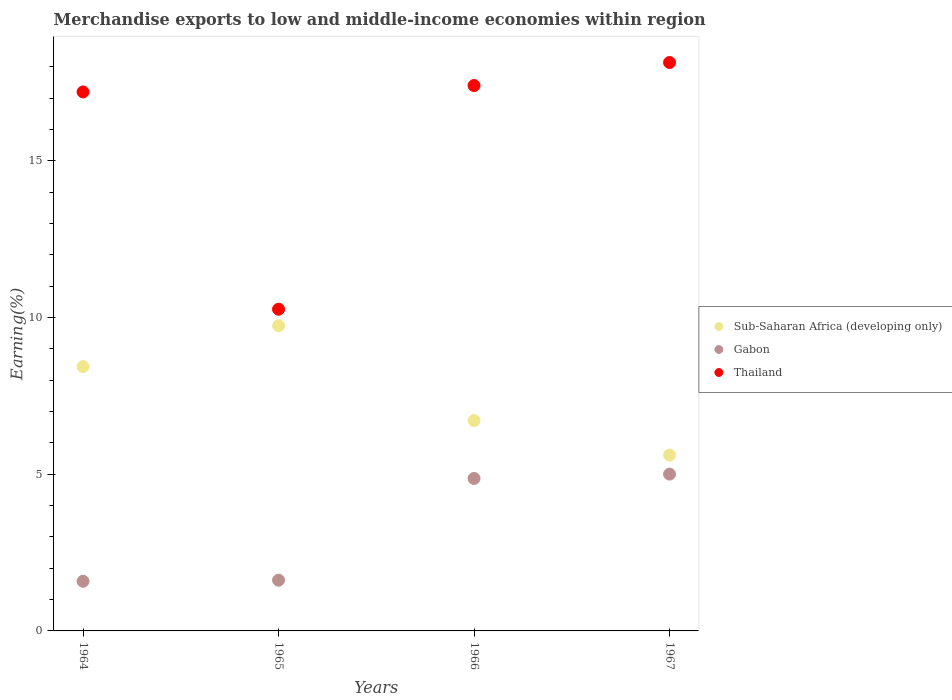What is the percentage of amount earned from merchandise exports in Gabon in 1967?
Provide a succinct answer. 5. Across all years, what is the maximum percentage of amount earned from merchandise exports in Sub-Saharan Africa (developing only)?
Provide a succinct answer. 9.74. Across all years, what is the minimum percentage of amount earned from merchandise exports in Thailand?
Offer a terse response. 10.27. In which year was the percentage of amount earned from merchandise exports in Sub-Saharan Africa (developing only) maximum?
Keep it short and to the point. 1965. In which year was the percentage of amount earned from merchandise exports in Sub-Saharan Africa (developing only) minimum?
Provide a short and direct response. 1967. What is the total percentage of amount earned from merchandise exports in Sub-Saharan Africa (developing only) in the graph?
Provide a succinct answer. 30.5. What is the difference between the percentage of amount earned from merchandise exports in Thailand in 1966 and that in 1967?
Ensure brevity in your answer.  -0.73. What is the difference between the percentage of amount earned from merchandise exports in Thailand in 1966 and the percentage of amount earned from merchandise exports in Sub-Saharan Africa (developing only) in 1965?
Give a very brief answer. 7.67. What is the average percentage of amount earned from merchandise exports in Gabon per year?
Provide a succinct answer. 3.27. In the year 1967, what is the difference between the percentage of amount earned from merchandise exports in Sub-Saharan Africa (developing only) and percentage of amount earned from merchandise exports in Gabon?
Offer a very short reply. 0.61. In how many years, is the percentage of amount earned from merchandise exports in Gabon greater than 4 %?
Give a very brief answer. 2. What is the ratio of the percentage of amount earned from merchandise exports in Sub-Saharan Africa (developing only) in 1966 to that in 1967?
Your response must be concise. 1.2. Is the difference between the percentage of amount earned from merchandise exports in Sub-Saharan Africa (developing only) in 1964 and 1966 greater than the difference between the percentage of amount earned from merchandise exports in Gabon in 1964 and 1966?
Your answer should be compact. Yes. What is the difference between the highest and the second highest percentage of amount earned from merchandise exports in Sub-Saharan Africa (developing only)?
Ensure brevity in your answer.  1.3. What is the difference between the highest and the lowest percentage of amount earned from merchandise exports in Sub-Saharan Africa (developing only)?
Make the answer very short. 4.13. Is it the case that in every year, the sum of the percentage of amount earned from merchandise exports in Thailand and percentage of amount earned from merchandise exports in Gabon  is greater than the percentage of amount earned from merchandise exports in Sub-Saharan Africa (developing only)?
Offer a very short reply. Yes. Does the percentage of amount earned from merchandise exports in Gabon monotonically increase over the years?
Offer a terse response. Yes. How many dotlines are there?
Ensure brevity in your answer.  3. How many years are there in the graph?
Your response must be concise. 4. Does the graph contain grids?
Ensure brevity in your answer.  No. How many legend labels are there?
Make the answer very short. 3. How are the legend labels stacked?
Your response must be concise. Vertical. What is the title of the graph?
Your answer should be compact. Merchandise exports to low and middle-income economies within region. Does "Channel Islands" appear as one of the legend labels in the graph?
Your response must be concise. No. What is the label or title of the Y-axis?
Your answer should be very brief. Earning(%). What is the Earning(%) of Sub-Saharan Africa (developing only) in 1964?
Offer a very short reply. 8.44. What is the Earning(%) in Gabon in 1964?
Your answer should be compact. 1.58. What is the Earning(%) of Thailand in 1964?
Provide a short and direct response. 17.2. What is the Earning(%) of Sub-Saharan Africa (developing only) in 1965?
Your answer should be compact. 9.74. What is the Earning(%) in Gabon in 1965?
Offer a terse response. 1.62. What is the Earning(%) in Thailand in 1965?
Make the answer very short. 10.27. What is the Earning(%) of Sub-Saharan Africa (developing only) in 1966?
Offer a terse response. 6.71. What is the Earning(%) in Gabon in 1966?
Offer a terse response. 4.87. What is the Earning(%) in Thailand in 1966?
Offer a very short reply. 17.41. What is the Earning(%) of Sub-Saharan Africa (developing only) in 1967?
Make the answer very short. 5.61. What is the Earning(%) of Gabon in 1967?
Keep it short and to the point. 5. What is the Earning(%) in Thailand in 1967?
Your answer should be compact. 18.14. Across all years, what is the maximum Earning(%) in Sub-Saharan Africa (developing only)?
Your answer should be compact. 9.74. Across all years, what is the maximum Earning(%) of Gabon?
Ensure brevity in your answer.  5. Across all years, what is the maximum Earning(%) of Thailand?
Your response must be concise. 18.14. Across all years, what is the minimum Earning(%) in Sub-Saharan Africa (developing only)?
Give a very brief answer. 5.61. Across all years, what is the minimum Earning(%) in Gabon?
Your answer should be very brief. 1.58. Across all years, what is the minimum Earning(%) in Thailand?
Make the answer very short. 10.27. What is the total Earning(%) in Sub-Saharan Africa (developing only) in the graph?
Your response must be concise. 30.5. What is the total Earning(%) of Gabon in the graph?
Your response must be concise. 13.07. What is the total Earning(%) in Thailand in the graph?
Provide a succinct answer. 63.02. What is the difference between the Earning(%) in Sub-Saharan Africa (developing only) in 1964 and that in 1965?
Your response must be concise. -1.3. What is the difference between the Earning(%) of Gabon in 1964 and that in 1965?
Give a very brief answer. -0.04. What is the difference between the Earning(%) in Thailand in 1964 and that in 1965?
Make the answer very short. 6.93. What is the difference between the Earning(%) in Sub-Saharan Africa (developing only) in 1964 and that in 1966?
Ensure brevity in your answer.  1.72. What is the difference between the Earning(%) in Gabon in 1964 and that in 1966?
Provide a succinct answer. -3.28. What is the difference between the Earning(%) in Thailand in 1964 and that in 1966?
Make the answer very short. -0.2. What is the difference between the Earning(%) in Sub-Saharan Africa (developing only) in 1964 and that in 1967?
Provide a succinct answer. 2.82. What is the difference between the Earning(%) of Gabon in 1964 and that in 1967?
Provide a short and direct response. -3.42. What is the difference between the Earning(%) of Thailand in 1964 and that in 1967?
Provide a short and direct response. -0.94. What is the difference between the Earning(%) of Sub-Saharan Africa (developing only) in 1965 and that in 1966?
Your response must be concise. 3.03. What is the difference between the Earning(%) of Gabon in 1965 and that in 1966?
Ensure brevity in your answer.  -3.25. What is the difference between the Earning(%) of Thailand in 1965 and that in 1966?
Your answer should be very brief. -7.14. What is the difference between the Earning(%) in Sub-Saharan Africa (developing only) in 1965 and that in 1967?
Your answer should be compact. 4.13. What is the difference between the Earning(%) in Gabon in 1965 and that in 1967?
Your answer should be compact. -3.39. What is the difference between the Earning(%) of Thailand in 1965 and that in 1967?
Ensure brevity in your answer.  -7.87. What is the difference between the Earning(%) of Sub-Saharan Africa (developing only) in 1966 and that in 1967?
Offer a very short reply. 1.1. What is the difference between the Earning(%) in Gabon in 1966 and that in 1967?
Offer a terse response. -0.14. What is the difference between the Earning(%) of Thailand in 1966 and that in 1967?
Provide a succinct answer. -0.73. What is the difference between the Earning(%) of Sub-Saharan Africa (developing only) in 1964 and the Earning(%) of Gabon in 1965?
Your answer should be compact. 6.82. What is the difference between the Earning(%) of Sub-Saharan Africa (developing only) in 1964 and the Earning(%) of Thailand in 1965?
Provide a short and direct response. -1.83. What is the difference between the Earning(%) of Gabon in 1964 and the Earning(%) of Thailand in 1965?
Your answer should be very brief. -8.68. What is the difference between the Earning(%) in Sub-Saharan Africa (developing only) in 1964 and the Earning(%) in Gabon in 1966?
Your answer should be very brief. 3.57. What is the difference between the Earning(%) of Sub-Saharan Africa (developing only) in 1964 and the Earning(%) of Thailand in 1966?
Your answer should be very brief. -8.97. What is the difference between the Earning(%) in Gabon in 1964 and the Earning(%) in Thailand in 1966?
Keep it short and to the point. -15.82. What is the difference between the Earning(%) in Sub-Saharan Africa (developing only) in 1964 and the Earning(%) in Gabon in 1967?
Give a very brief answer. 3.43. What is the difference between the Earning(%) in Sub-Saharan Africa (developing only) in 1964 and the Earning(%) in Thailand in 1967?
Your response must be concise. -9.71. What is the difference between the Earning(%) of Gabon in 1964 and the Earning(%) of Thailand in 1967?
Make the answer very short. -16.56. What is the difference between the Earning(%) in Sub-Saharan Africa (developing only) in 1965 and the Earning(%) in Gabon in 1966?
Ensure brevity in your answer.  4.87. What is the difference between the Earning(%) of Sub-Saharan Africa (developing only) in 1965 and the Earning(%) of Thailand in 1966?
Provide a short and direct response. -7.67. What is the difference between the Earning(%) in Gabon in 1965 and the Earning(%) in Thailand in 1966?
Your answer should be compact. -15.79. What is the difference between the Earning(%) in Sub-Saharan Africa (developing only) in 1965 and the Earning(%) in Gabon in 1967?
Provide a short and direct response. 4.74. What is the difference between the Earning(%) in Sub-Saharan Africa (developing only) in 1965 and the Earning(%) in Thailand in 1967?
Your response must be concise. -8.4. What is the difference between the Earning(%) in Gabon in 1965 and the Earning(%) in Thailand in 1967?
Give a very brief answer. -16.52. What is the difference between the Earning(%) in Sub-Saharan Africa (developing only) in 1966 and the Earning(%) in Gabon in 1967?
Keep it short and to the point. 1.71. What is the difference between the Earning(%) in Sub-Saharan Africa (developing only) in 1966 and the Earning(%) in Thailand in 1967?
Ensure brevity in your answer.  -11.43. What is the difference between the Earning(%) of Gabon in 1966 and the Earning(%) of Thailand in 1967?
Offer a very short reply. -13.27. What is the average Earning(%) in Sub-Saharan Africa (developing only) per year?
Offer a terse response. 7.63. What is the average Earning(%) in Gabon per year?
Your answer should be compact. 3.27. What is the average Earning(%) in Thailand per year?
Give a very brief answer. 15.75. In the year 1964, what is the difference between the Earning(%) of Sub-Saharan Africa (developing only) and Earning(%) of Gabon?
Make the answer very short. 6.85. In the year 1964, what is the difference between the Earning(%) in Sub-Saharan Africa (developing only) and Earning(%) in Thailand?
Provide a short and direct response. -8.77. In the year 1964, what is the difference between the Earning(%) of Gabon and Earning(%) of Thailand?
Your answer should be compact. -15.62. In the year 1965, what is the difference between the Earning(%) of Sub-Saharan Africa (developing only) and Earning(%) of Gabon?
Your response must be concise. 8.12. In the year 1965, what is the difference between the Earning(%) of Sub-Saharan Africa (developing only) and Earning(%) of Thailand?
Ensure brevity in your answer.  -0.53. In the year 1965, what is the difference between the Earning(%) in Gabon and Earning(%) in Thailand?
Offer a terse response. -8.65. In the year 1966, what is the difference between the Earning(%) in Sub-Saharan Africa (developing only) and Earning(%) in Gabon?
Offer a terse response. 1.85. In the year 1966, what is the difference between the Earning(%) in Sub-Saharan Africa (developing only) and Earning(%) in Thailand?
Keep it short and to the point. -10.69. In the year 1966, what is the difference between the Earning(%) of Gabon and Earning(%) of Thailand?
Offer a terse response. -12.54. In the year 1967, what is the difference between the Earning(%) in Sub-Saharan Africa (developing only) and Earning(%) in Gabon?
Your answer should be compact. 0.61. In the year 1967, what is the difference between the Earning(%) in Sub-Saharan Africa (developing only) and Earning(%) in Thailand?
Your response must be concise. -12.53. In the year 1967, what is the difference between the Earning(%) of Gabon and Earning(%) of Thailand?
Keep it short and to the point. -13.14. What is the ratio of the Earning(%) of Sub-Saharan Africa (developing only) in 1964 to that in 1965?
Give a very brief answer. 0.87. What is the ratio of the Earning(%) of Gabon in 1964 to that in 1965?
Make the answer very short. 0.98. What is the ratio of the Earning(%) in Thailand in 1964 to that in 1965?
Your response must be concise. 1.68. What is the ratio of the Earning(%) of Sub-Saharan Africa (developing only) in 1964 to that in 1966?
Your answer should be very brief. 1.26. What is the ratio of the Earning(%) in Gabon in 1964 to that in 1966?
Offer a terse response. 0.33. What is the ratio of the Earning(%) in Sub-Saharan Africa (developing only) in 1964 to that in 1967?
Your answer should be compact. 1.5. What is the ratio of the Earning(%) in Gabon in 1964 to that in 1967?
Keep it short and to the point. 0.32. What is the ratio of the Earning(%) of Thailand in 1964 to that in 1967?
Offer a terse response. 0.95. What is the ratio of the Earning(%) in Sub-Saharan Africa (developing only) in 1965 to that in 1966?
Provide a succinct answer. 1.45. What is the ratio of the Earning(%) of Gabon in 1965 to that in 1966?
Provide a short and direct response. 0.33. What is the ratio of the Earning(%) of Thailand in 1965 to that in 1966?
Offer a terse response. 0.59. What is the ratio of the Earning(%) of Sub-Saharan Africa (developing only) in 1965 to that in 1967?
Make the answer very short. 1.74. What is the ratio of the Earning(%) of Gabon in 1965 to that in 1967?
Offer a terse response. 0.32. What is the ratio of the Earning(%) of Thailand in 1965 to that in 1967?
Offer a terse response. 0.57. What is the ratio of the Earning(%) in Sub-Saharan Africa (developing only) in 1966 to that in 1967?
Provide a succinct answer. 1.2. What is the ratio of the Earning(%) in Gabon in 1966 to that in 1967?
Give a very brief answer. 0.97. What is the ratio of the Earning(%) of Thailand in 1966 to that in 1967?
Provide a short and direct response. 0.96. What is the difference between the highest and the second highest Earning(%) in Sub-Saharan Africa (developing only)?
Offer a very short reply. 1.3. What is the difference between the highest and the second highest Earning(%) in Gabon?
Offer a terse response. 0.14. What is the difference between the highest and the second highest Earning(%) of Thailand?
Keep it short and to the point. 0.73. What is the difference between the highest and the lowest Earning(%) in Sub-Saharan Africa (developing only)?
Make the answer very short. 4.13. What is the difference between the highest and the lowest Earning(%) in Gabon?
Your answer should be very brief. 3.42. What is the difference between the highest and the lowest Earning(%) in Thailand?
Provide a short and direct response. 7.87. 